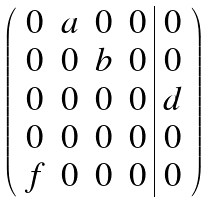Convert formula to latex. <formula><loc_0><loc_0><loc_500><loc_500>\left ( \begin{array} { c c c c | c } 0 & a & 0 & 0 & 0 \\ 0 & 0 & b & 0 & 0 \\ 0 & 0 & 0 & 0 & d \\ 0 & 0 & 0 & 0 & 0 \\ f & 0 & 0 & 0 & 0 \end{array} \right )</formula> 